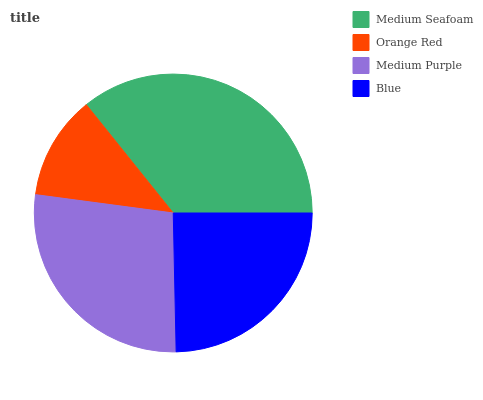Is Orange Red the minimum?
Answer yes or no. Yes. Is Medium Seafoam the maximum?
Answer yes or no. Yes. Is Medium Purple the minimum?
Answer yes or no. No. Is Medium Purple the maximum?
Answer yes or no. No. Is Medium Purple greater than Orange Red?
Answer yes or no. Yes. Is Orange Red less than Medium Purple?
Answer yes or no. Yes. Is Orange Red greater than Medium Purple?
Answer yes or no. No. Is Medium Purple less than Orange Red?
Answer yes or no. No. Is Medium Purple the high median?
Answer yes or no. Yes. Is Blue the low median?
Answer yes or no. Yes. Is Medium Seafoam the high median?
Answer yes or no. No. Is Medium Seafoam the low median?
Answer yes or no. No. 